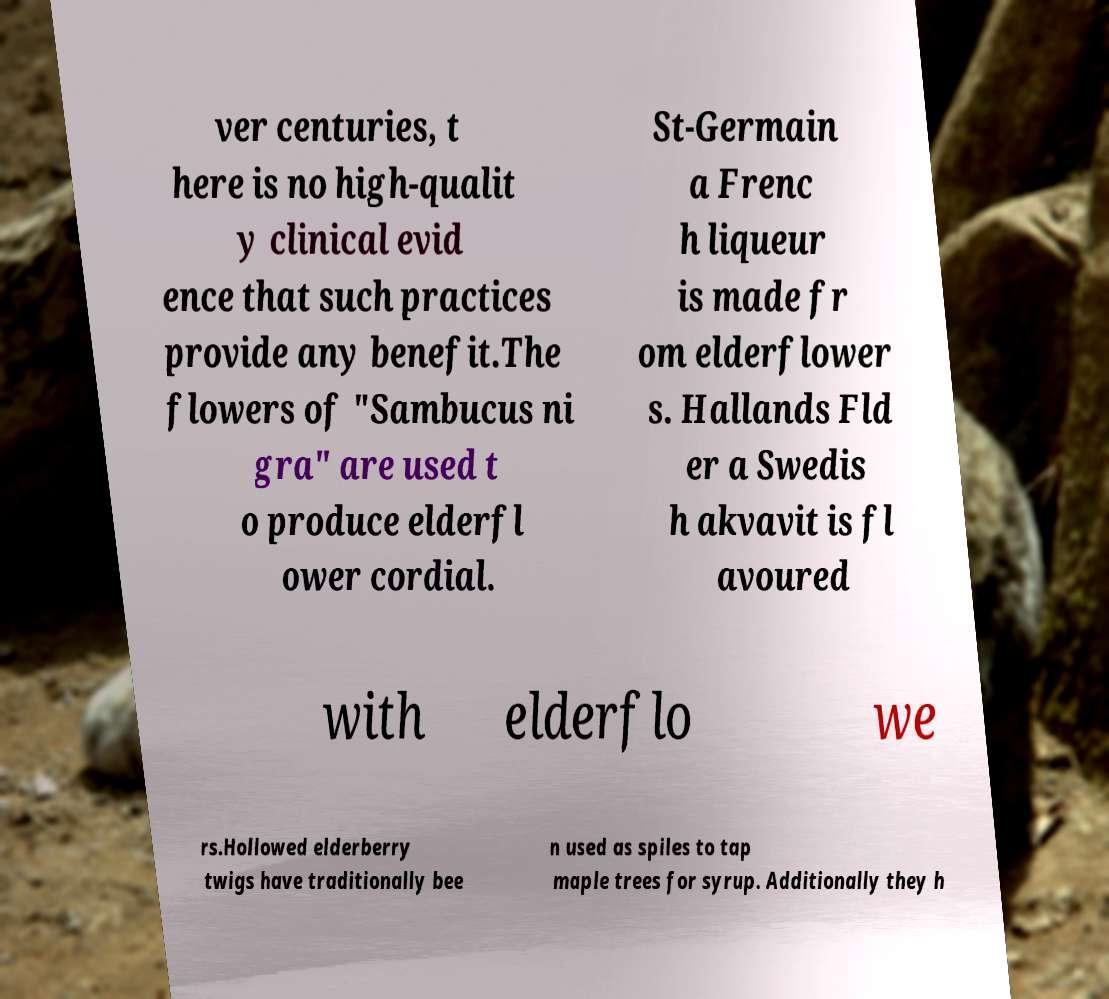I need the written content from this picture converted into text. Can you do that? ver centuries, t here is no high-qualit y clinical evid ence that such practices provide any benefit.The flowers of "Sambucus ni gra" are used t o produce elderfl ower cordial. St-Germain a Frenc h liqueur is made fr om elderflower s. Hallands Fld er a Swedis h akvavit is fl avoured with elderflo we rs.Hollowed elderberry twigs have traditionally bee n used as spiles to tap maple trees for syrup. Additionally they h 